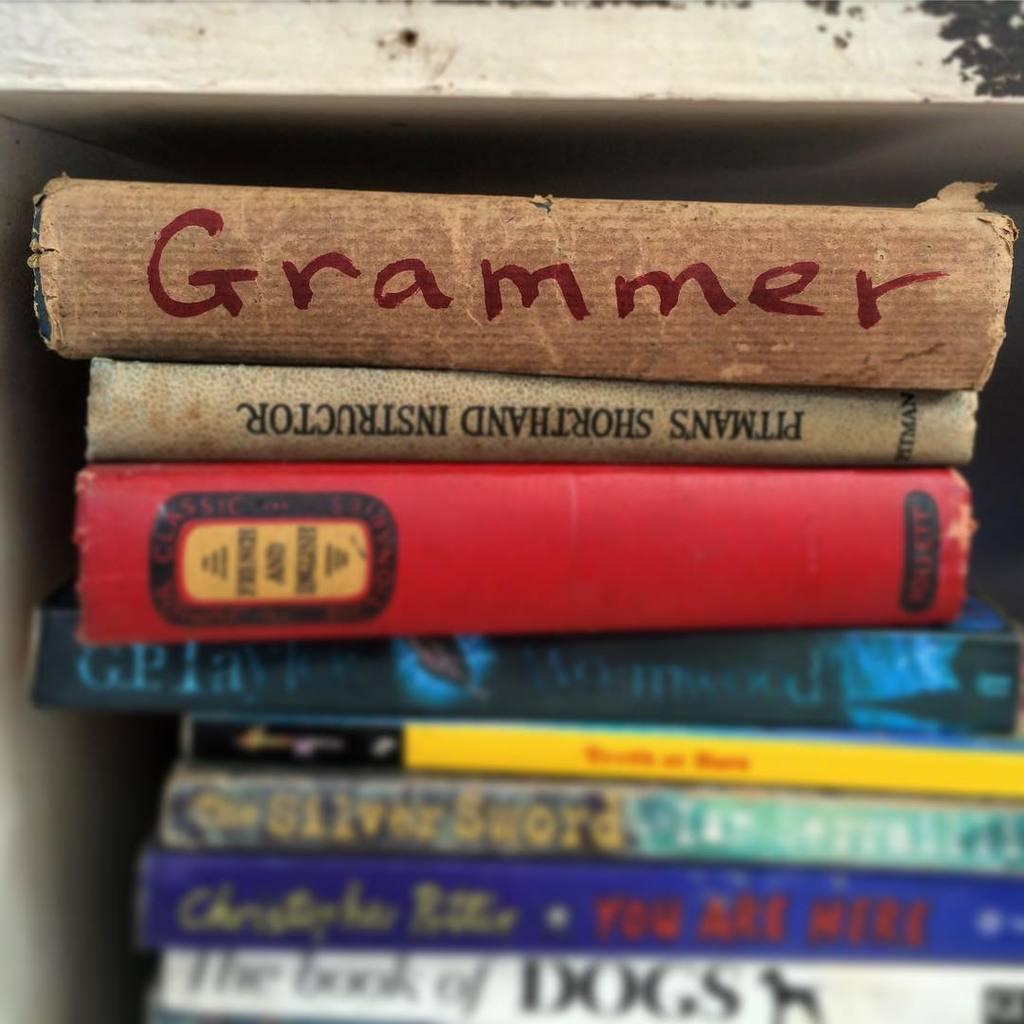<image>
Create a compact narrative representing the image presented. Grammer book with Pitmans Shorthand Instructor book below it. 